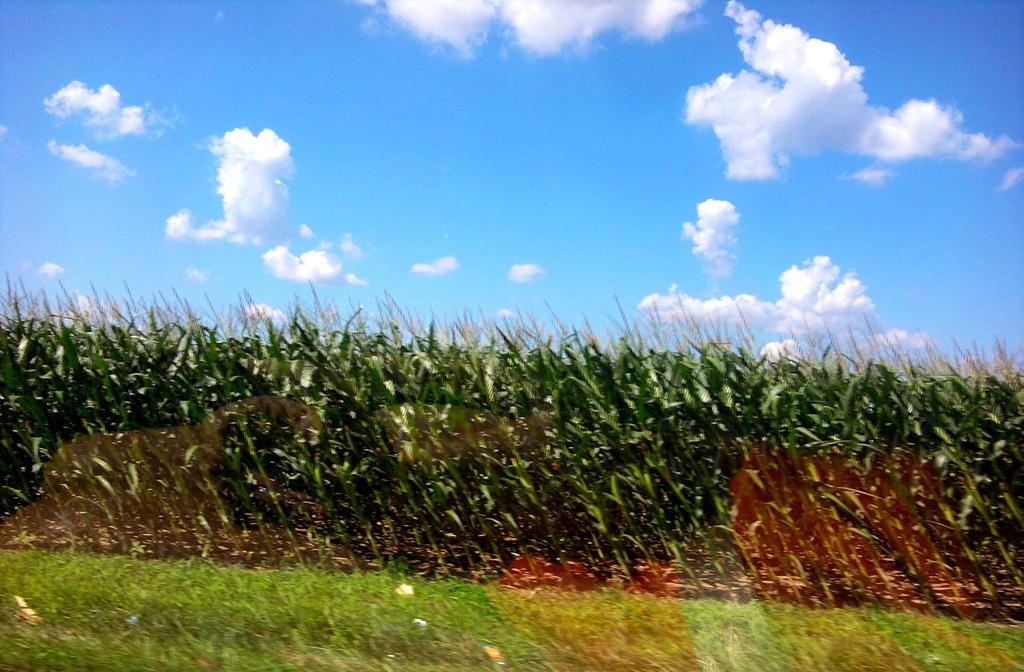Can you describe this image briefly? There are many crops and in front of the crops there is a grass and the picture is captured from behind the grass. 